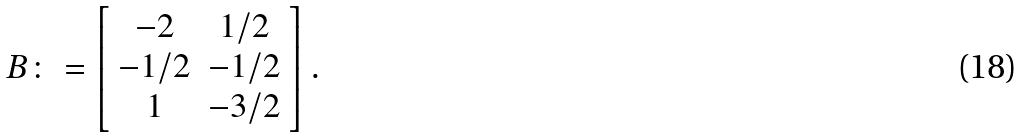Convert formula to latex. <formula><loc_0><loc_0><loc_500><loc_500>B \colon = \left [ \begin{array} { c c } - 2 & 1 / 2 \\ - 1 / 2 & - 1 / 2 \\ 1 & - 3 / 2 \\ \end{array} \right ] .</formula> 